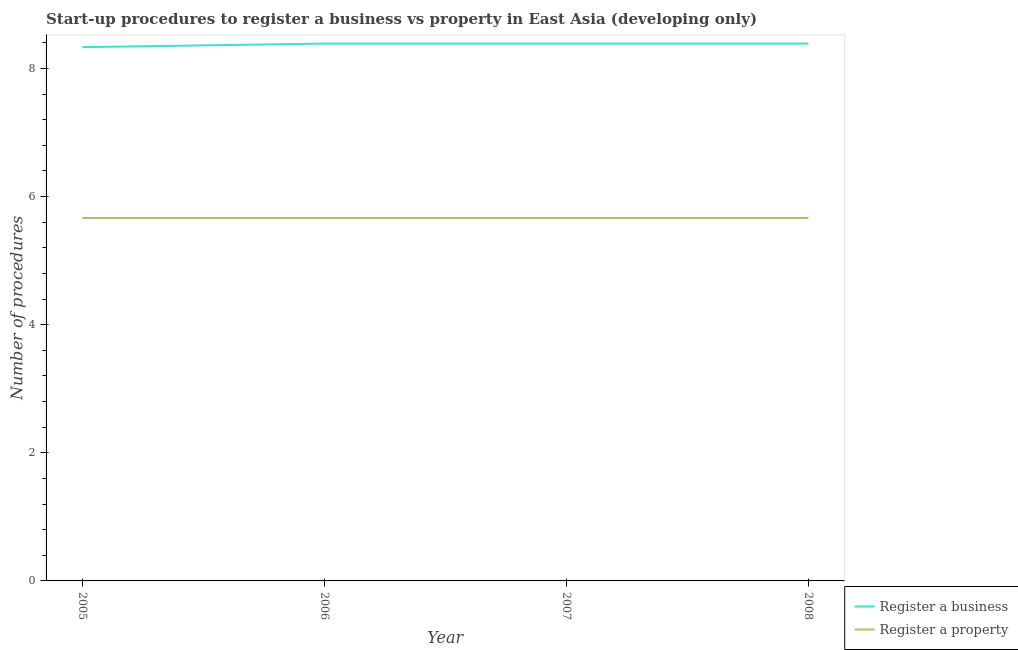How many different coloured lines are there?
Offer a very short reply. 2. What is the number of procedures to register a property in 2008?
Ensure brevity in your answer.  5.67. Across all years, what is the maximum number of procedures to register a business?
Offer a terse response. 8.39. Across all years, what is the minimum number of procedures to register a business?
Keep it short and to the point. 8.33. In which year was the number of procedures to register a business minimum?
Your response must be concise. 2005. What is the total number of procedures to register a property in the graph?
Provide a succinct answer. 22.67. What is the difference between the number of procedures to register a property in 2007 and that in 2008?
Offer a terse response. 0. What is the difference between the number of procedures to register a property in 2007 and the number of procedures to register a business in 2008?
Offer a terse response. -2.72. What is the average number of procedures to register a business per year?
Your answer should be compact. 8.38. In the year 2007, what is the difference between the number of procedures to register a business and number of procedures to register a property?
Your answer should be very brief. 2.72. What is the ratio of the number of procedures to register a business in 2006 to that in 2008?
Give a very brief answer. 1. Is the number of procedures to register a property in 2006 less than that in 2007?
Your response must be concise. No. Is the difference between the number of procedures to register a business in 2006 and 2008 greater than the difference between the number of procedures to register a property in 2006 and 2008?
Keep it short and to the point. No. What is the difference between the highest and the lowest number of procedures to register a business?
Keep it short and to the point. 0.06. In how many years, is the number of procedures to register a business greater than the average number of procedures to register a business taken over all years?
Give a very brief answer. 3. Is the sum of the number of procedures to register a business in 2006 and 2007 greater than the maximum number of procedures to register a property across all years?
Provide a succinct answer. Yes. Is the number of procedures to register a business strictly greater than the number of procedures to register a property over the years?
Offer a very short reply. Yes. How many lines are there?
Offer a terse response. 2. Are the values on the major ticks of Y-axis written in scientific E-notation?
Your answer should be compact. No. Does the graph contain grids?
Your response must be concise. No. Where does the legend appear in the graph?
Make the answer very short. Bottom right. How many legend labels are there?
Provide a short and direct response. 2. How are the legend labels stacked?
Ensure brevity in your answer.  Vertical. What is the title of the graph?
Provide a succinct answer. Start-up procedures to register a business vs property in East Asia (developing only). What is the label or title of the Y-axis?
Offer a very short reply. Number of procedures. What is the Number of procedures of Register a business in 2005?
Ensure brevity in your answer.  8.33. What is the Number of procedures in Register a property in 2005?
Offer a very short reply. 5.67. What is the Number of procedures in Register a business in 2006?
Offer a very short reply. 8.39. What is the Number of procedures of Register a property in 2006?
Offer a very short reply. 5.67. What is the Number of procedures of Register a business in 2007?
Make the answer very short. 8.39. What is the Number of procedures of Register a property in 2007?
Make the answer very short. 5.67. What is the Number of procedures of Register a business in 2008?
Offer a terse response. 8.39. What is the Number of procedures of Register a property in 2008?
Provide a short and direct response. 5.67. Across all years, what is the maximum Number of procedures in Register a business?
Keep it short and to the point. 8.39. Across all years, what is the maximum Number of procedures of Register a property?
Keep it short and to the point. 5.67. Across all years, what is the minimum Number of procedures of Register a business?
Offer a very short reply. 8.33. Across all years, what is the minimum Number of procedures of Register a property?
Your answer should be very brief. 5.67. What is the total Number of procedures in Register a business in the graph?
Your answer should be compact. 33.5. What is the total Number of procedures in Register a property in the graph?
Your answer should be very brief. 22.67. What is the difference between the Number of procedures in Register a business in 2005 and that in 2006?
Provide a succinct answer. -0.06. What is the difference between the Number of procedures of Register a property in 2005 and that in 2006?
Your response must be concise. 0. What is the difference between the Number of procedures of Register a business in 2005 and that in 2007?
Provide a short and direct response. -0.06. What is the difference between the Number of procedures of Register a property in 2005 and that in 2007?
Give a very brief answer. 0. What is the difference between the Number of procedures of Register a business in 2005 and that in 2008?
Provide a short and direct response. -0.06. What is the difference between the Number of procedures of Register a property in 2005 and that in 2008?
Give a very brief answer. 0. What is the difference between the Number of procedures of Register a business in 2006 and that in 2007?
Your answer should be compact. 0. What is the difference between the Number of procedures in Register a property in 2006 and that in 2007?
Ensure brevity in your answer.  0. What is the difference between the Number of procedures of Register a business in 2006 and that in 2008?
Ensure brevity in your answer.  0. What is the difference between the Number of procedures in Register a business in 2007 and that in 2008?
Provide a succinct answer. 0. What is the difference between the Number of procedures in Register a property in 2007 and that in 2008?
Provide a short and direct response. 0. What is the difference between the Number of procedures in Register a business in 2005 and the Number of procedures in Register a property in 2006?
Provide a succinct answer. 2.67. What is the difference between the Number of procedures of Register a business in 2005 and the Number of procedures of Register a property in 2007?
Provide a short and direct response. 2.67. What is the difference between the Number of procedures of Register a business in 2005 and the Number of procedures of Register a property in 2008?
Offer a very short reply. 2.67. What is the difference between the Number of procedures in Register a business in 2006 and the Number of procedures in Register a property in 2007?
Your answer should be compact. 2.72. What is the difference between the Number of procedures of Register a business in 2006 and the Number of procedures of Register a property in 2008?
Your response must be concise. 2.72. What is the difference between the Number of procedures of Register a business in 2007 and the Number of procedures of Register a property in 2008?
Your answer should be compact. 2.72. What is the average Number of procedures in Register a business per year?
Offer a terse response. 8.38. What is the average Number of procedures in Register a property per year?
Offer a very short reply. 5.67. In the year 2005, what is the difference between the Number of procedures of Register a business and Number of procedures of Register a property?
Ensure brevity in your answer.  2.67. In the year 2006, what is the difference between the Number of procedures of Register a business and Number of procedures of Register a property?
Make the answer very short. 2.72. In the year 2007, what is the difference between the Number of procedures in Register a business and Number of procedures in Register a property?
Your answer should be very brief. 2.72. In the year 2008, what is the difference between the Number of procedures in Register a business and Number of procedures in Register a property?
Your answer should be very brief. 2.72. What is the ratio of the Number of procedures of Register a business in 2005 to that in 2006?
Provide a succinct answer. 0.99. What is the ratio of the Number of procedures of Register a business in 2005 to that in 2007?
Provide a short and direct response. 0.99. What is the ratio of the Number of procedures of Register a business in 2005 to that in 2008?
Offer a terse response. 0.99. What is the ratio of the Number of procedures of Register a business in 2006 to that in 2008?
Offer a very short reply. 1. What is the ratio of the Number of procedures of Register a business in 2007 to that in 2008?
Offer a very short reply. 1. What is the difference between the highest and the second highest Number of procedures of Register a business?
Offer a terse response. 0. What is the difference between the highest and the lowest Number of procedures in Register a business?
Keep it short and to the point. 0.06. What is the difference between the highest and the lowest Number of procedures in Register a property?
Give a very brief answer. 0. 